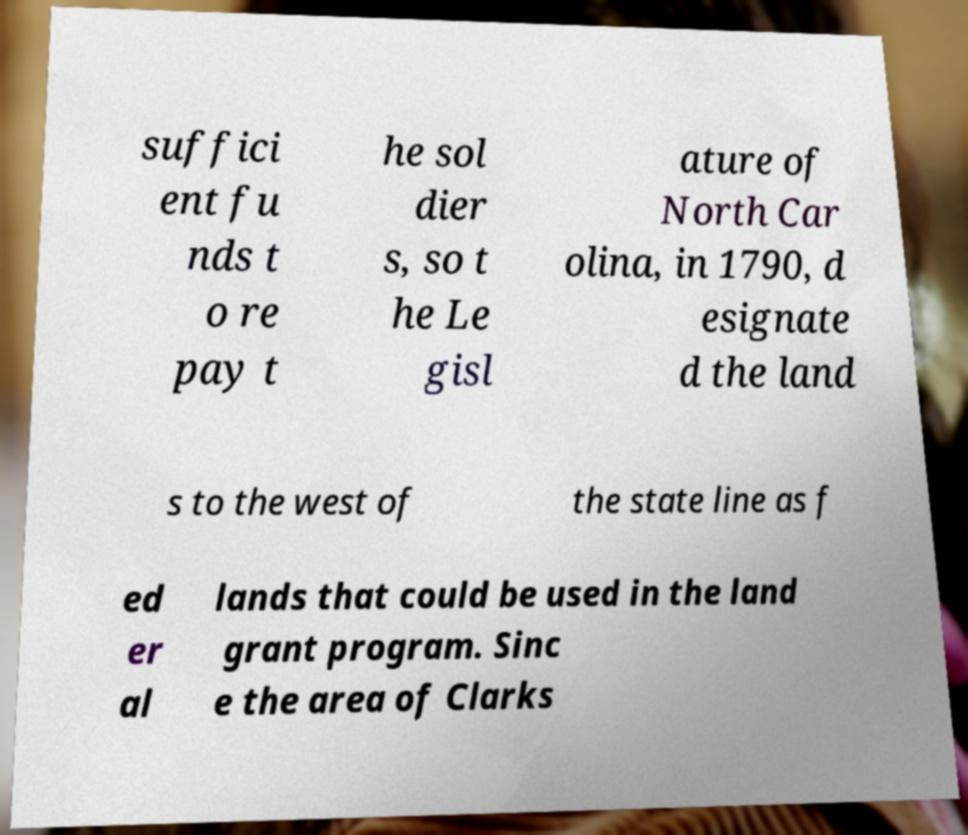I need the written content from this picture converted into text. Can you do that? suffici ent fu nds t o re pay t he sol dier s, so t he Le gisl ature of North Car olina, in 1790, d esignate d the land s to the west of the state line as f ed er al lands that could be used in the land grant program. Sinc e the area of Clarks 